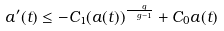<formula> <loc_0><loc_0><loc_500><loc_500>a ^ { \prime } ( t ) \leq - C _ { 1 } ( a ( t ) ) ^ { \frac { \ g } { \ g - 1 } } + C _ { 0 } a ( t )</formula> 